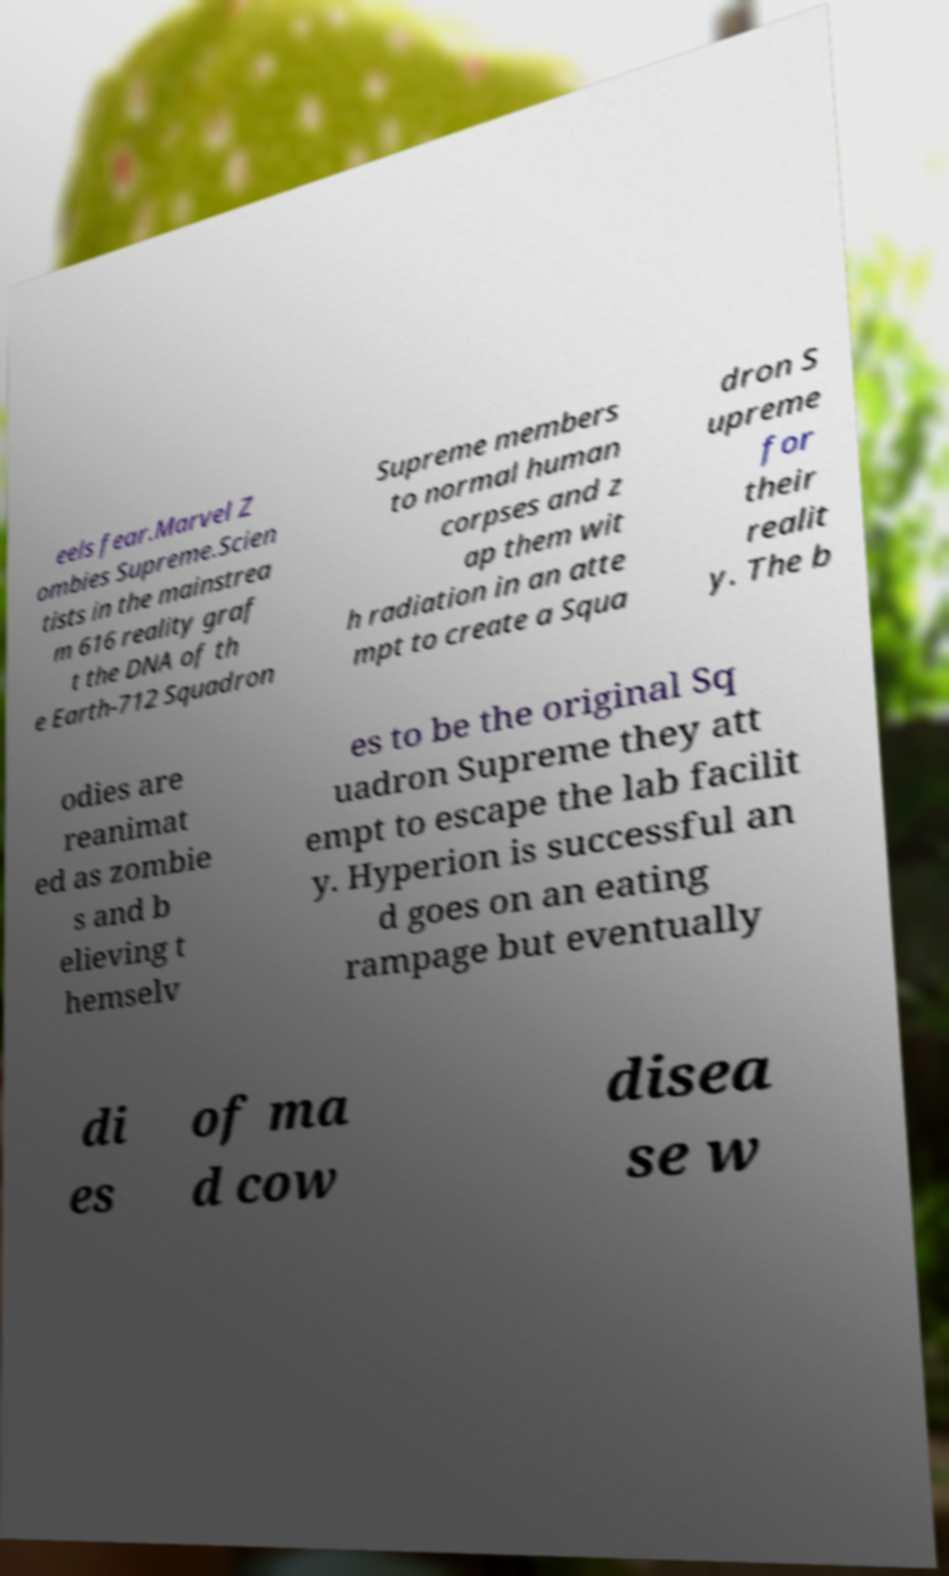Please identify and transcribe the text found in this image. eels fear.Marvel Z ombies Supreme.Scien tists in the mainstrea m 616 reality graf t the DNA of th e Earth-712 Squadron Supreme members to normal human corpses and z ap them wit h radiation in an atte mpt to create a Squa dron S upreme for their realit y. The b odies are reanimat ed as zombie s and b elieving t hemselv es to be the original Sq uadron Supreme they att empt to escape the lab facilit y. Hyperion is successful an d goes on an eating rampage but eventually di es of ma d cow disea se w 